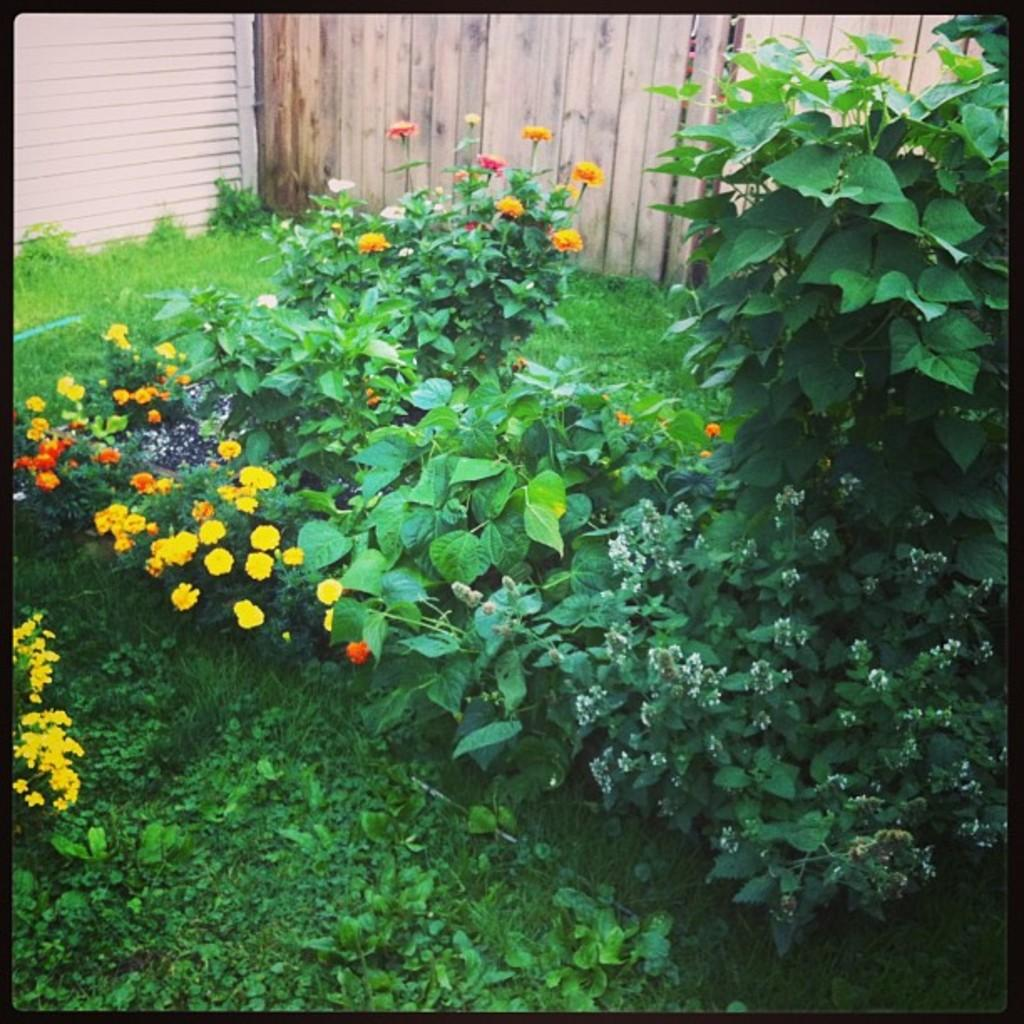What types of living organisms can be seen in the image? Plants and flowers are visible in the image. What is the purpose of the fence in the background of the image? The purpose of the fence in the background is not specified in the image, but it could be for enclosing or separating areas. Can you describe the plants and flowers in the image? The image shows plants with flowers, but the specific types of plants and flowers are not identifiable. What type of silk is being used to make the air in the image? There is no silk or air present in the image; it features plants and flowers with a fence in the background. 